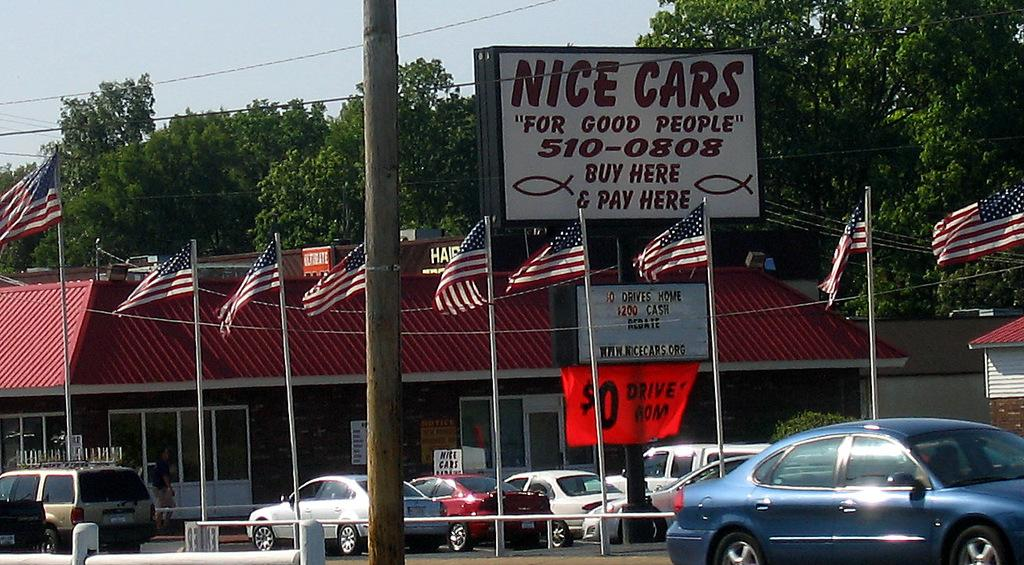What can be seen in the parking lot in the image? There are cars in a parking lot in the image. What structures are present in the image besides the parking lot? There are flagpoles and a board with text in the image. What can be seen in the background of the image? There are houses and trees in the background of the image. How does the board blow in the wind in the image? The board does not blow in the wind in the image; it is stationary. Can you tell me how many people are using the park in the image? There is no park present in the image; it features a parking lot with cars. 